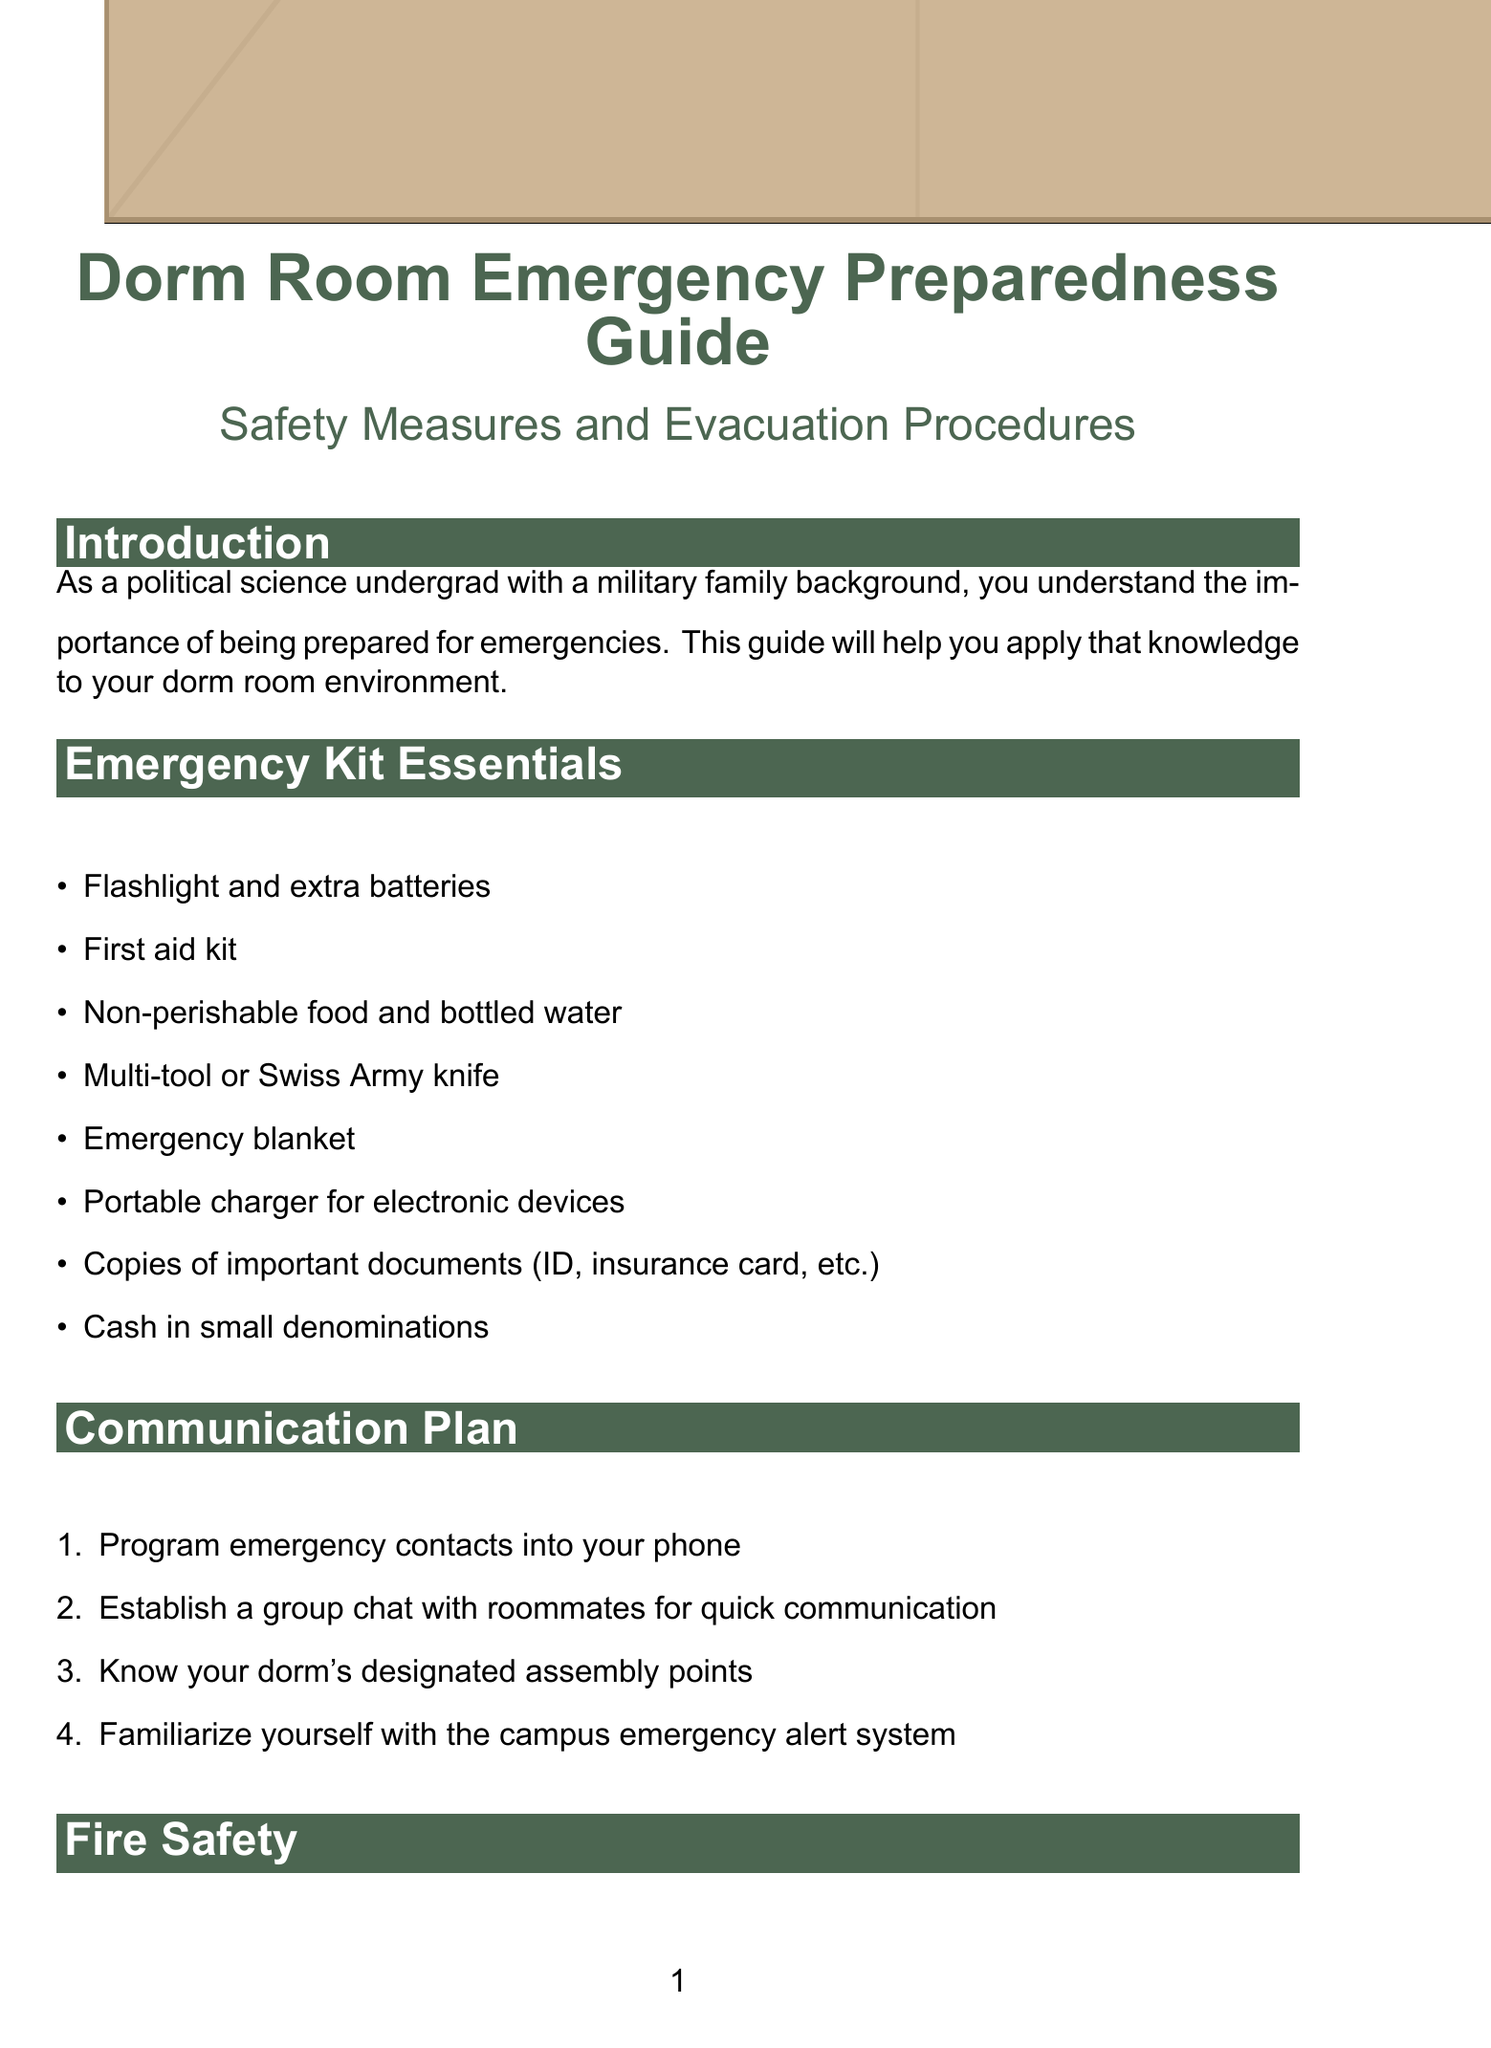What are the emergency kit essentials? The emergency kit essentials are listed in a section of the document, including items like a flashlight, first aid kit, and non-perishable food.
Answer: Flashlight, first aid kit, non-perishable food, bottled water, multi-tool, emergency blanket, portable charger, copies of important documents, cash What is the phone number for campus security? The document provides contact numbers for campus resources, including campus security.
Answer: 555-123-4567 What protocol should be followed in an active shooter situation? The guide outlines specific procedures to follow during an active shooter situation, including 'Run, Hide, Fight.'
Answer: Run, Hide, Fight How often should the emergency kit be reviewed and updated? There is a specific section addressing regular preparedness maintenance that mentions how often to update your emergency kit.
Answer: Monthly What should you do after an emergency? The document outlines post-emergency actions including checking in with family and reporting your status to campus authorities.
Answer: Check in with family and friends, report your status Where should you go during a tornado? The document explains the actions to take during a tornado, including where to seek shelter.
Answer: Lowest floor or interior hallway What is the first step in the evacuation procedures? The evacuation procedures include steps to follow, starting with remaining calm and following instructions.
Answer: Remain calm and follow instructions from authorities What is recommended for communication with roommates during an emergency? The document suggests establishing a group chat with roommates for quick communication as part of the communication plan.
Answer: Establish a group chat with roommates What techniques are practiced for fire safety? The document lists fire safety measures that include specific actions to take in the event of a fire.
Answer: Stop, drop, and roll 